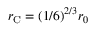<formula> <loc_0><loc_0><loc_500><loc_500>r _ { C } = ( 1 / 6 ) ^ { 2 / 3 } r _ { 0 }</formula> 